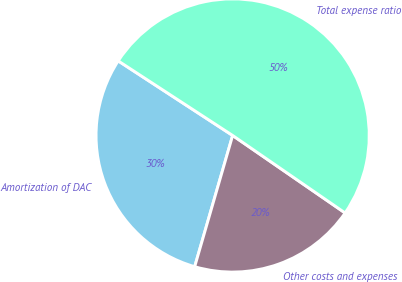Convert chart. <chart><loc_0><loc_0><loc_500><loc_500><pie_chart><fcel>Amortization of DAC<fcel>Other costs and expenses<fcel>Total expense ratio<nl><fcel>29.71%<fcel>19.88%<fcel>50.41%<nl></chart> 